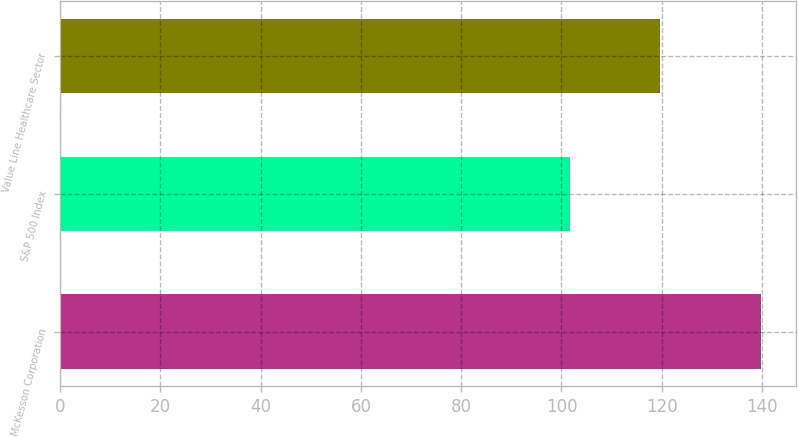Convert chart to OTSL. <chart><loc_0><loc_0><loc_500><loc_500><bar_chart><fcel>McKesson Corporation<fcel>S&P 500 Index<fcel>Value Line Healthcare Sector<nl><fcel>139.72<fcel>101.79<fcel>119.57<nl></chart> 